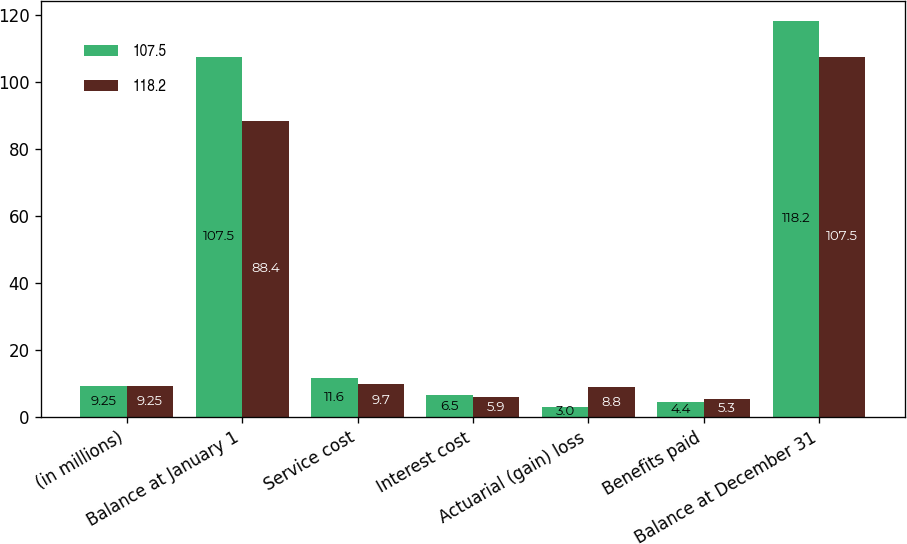<chart> <loc_0><loc_0><loc_500><loc_500><stacked_bar_chart><ecel><fcel>(in millions)<fcel>Balance at January 1<fcel>Service cost<fcel>Interest cost<fcel>Actuarial (gain) loss<fcel>Benefits paid<fcel>Balance at December 31<nl><fcel>107.5<fcel>9.25<fcel>107.5<fcel>11.6<fcel>6.5<fcel>3<fcel>4.4<fcel>118.2<nl><fcel>118.2<fcel>9.25<fcel>88.4<fcel>9.7<fcel>5.9<fcel>8.8<fcel>5.3<fcel>107.5<nl></chart> 